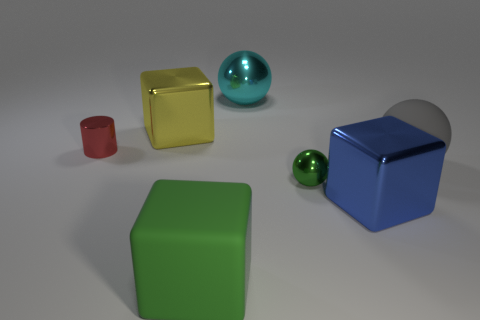Are there patterns or textures on any of the items in the image? No, all the objects in the image have solid colors and lack any distinct patterns or textures.  How does the lighting in the image interact with the objects? The lighting creates soft shadows on the ground and highlights the differences in texture by reflecting off the shiny surfaces while leaving the matte surfaces more uniformly lit. 